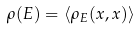Convert formula to latex. <formula><loc_0><loc_0><loc_500><loc_500>\rho ( E ) = \langle \rho _ { E } ( x , x ) \rangle</formula> 